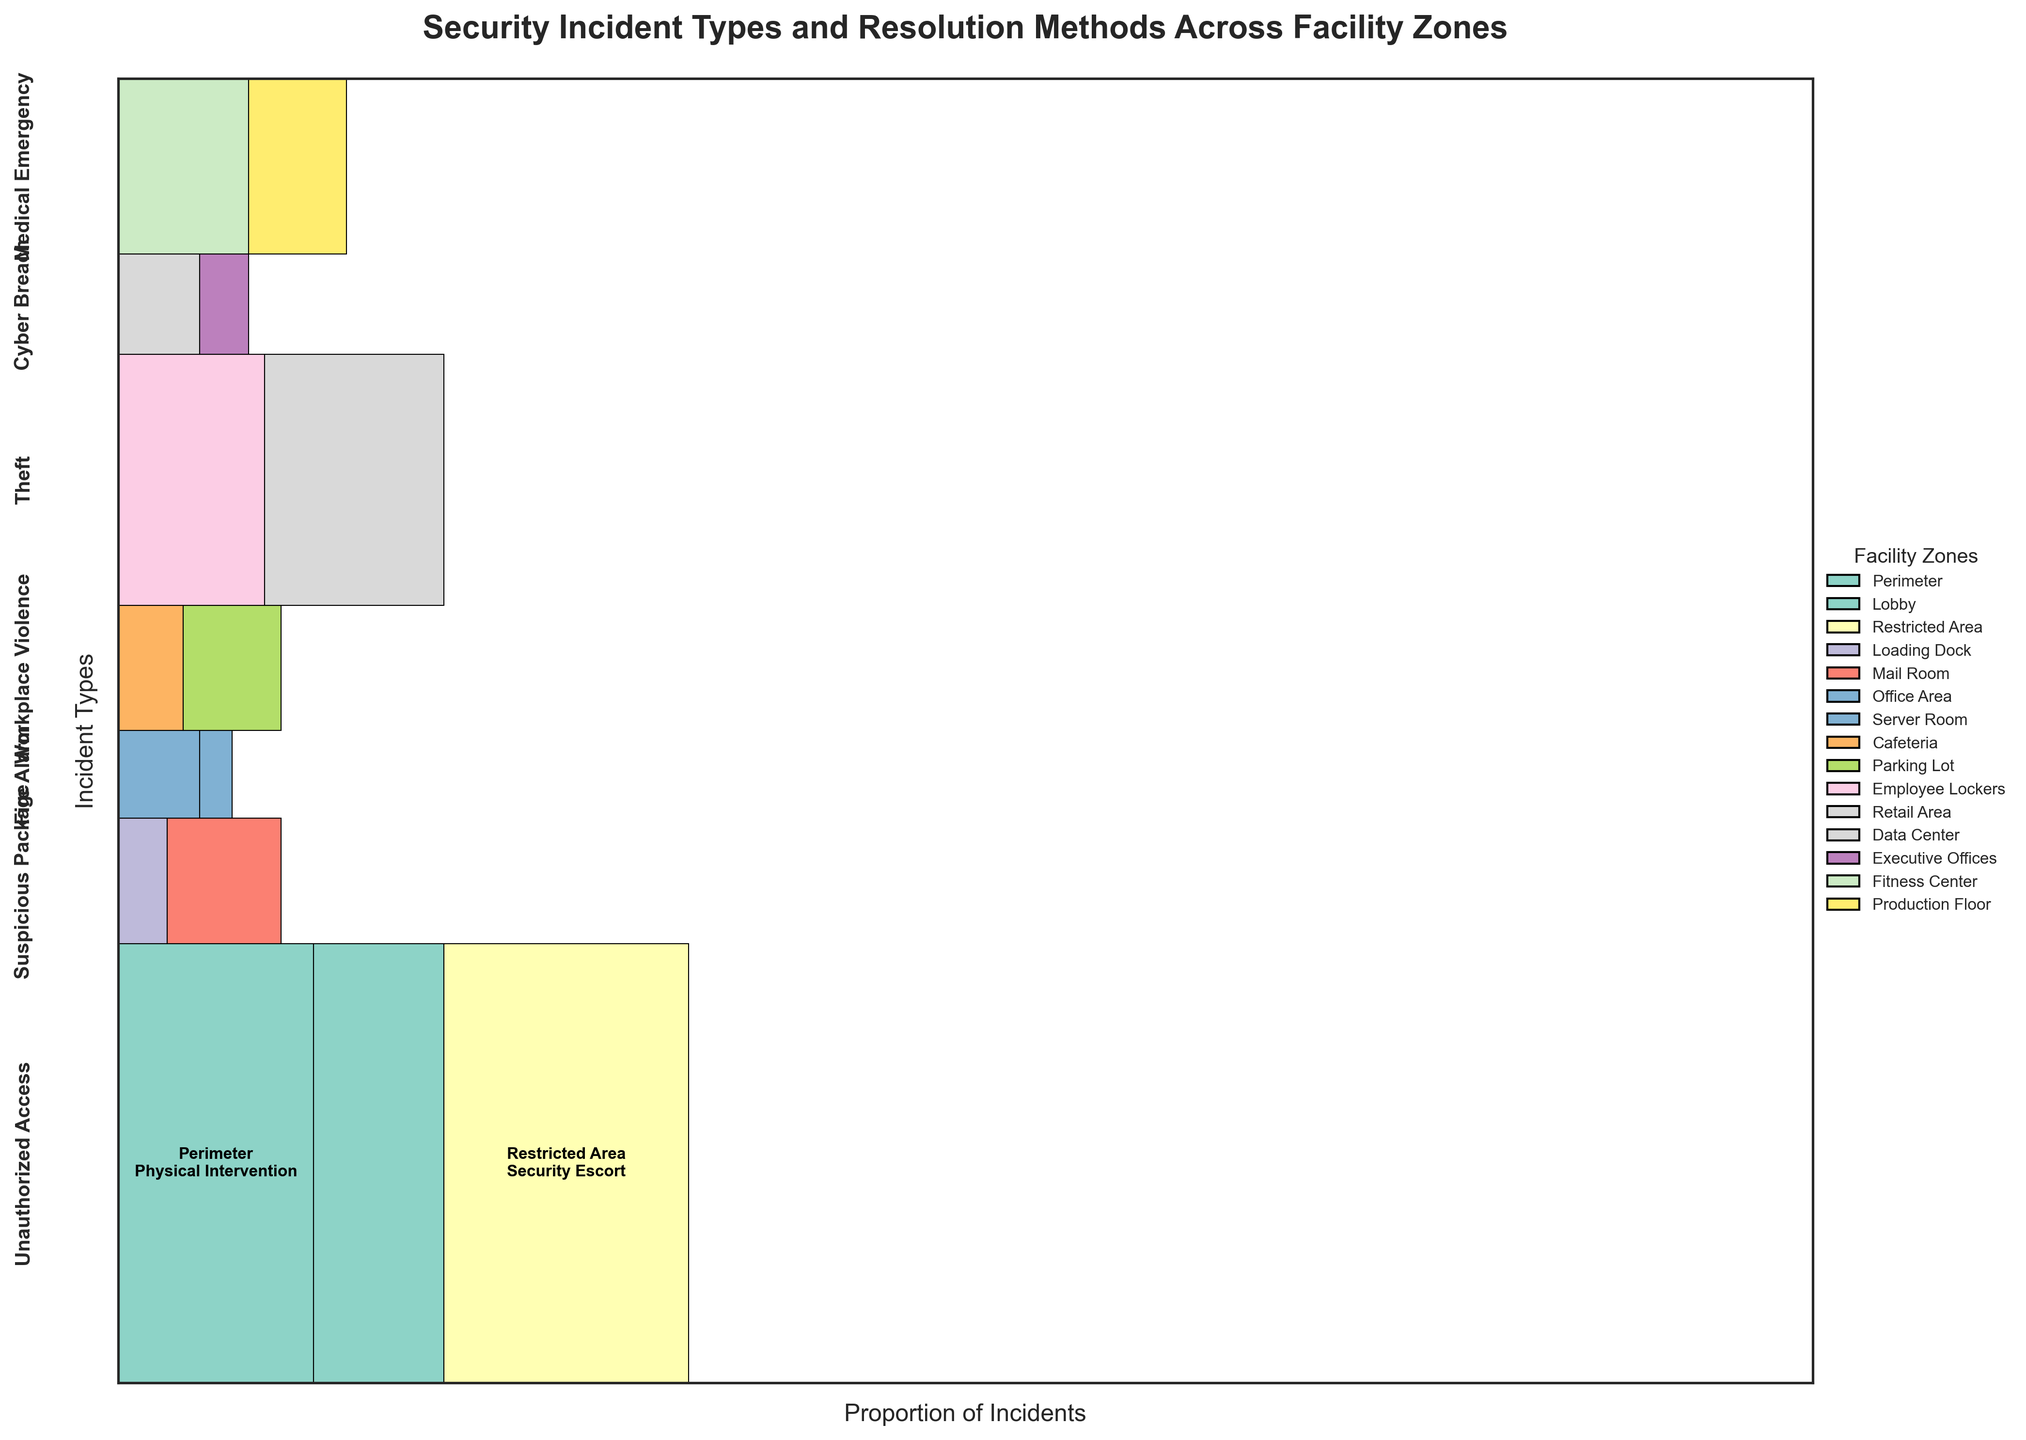what is the title of the plot? The title is usually located at the top of the figure. In this case, the title provides a summary of what the plot represents, which is "Security Incident Types and Resolution Methods Across Facility Zones".
Answer: Security Incident Types and Resolution Methods Across Facility Zones which incident type has the highest total frequency? To determine this, look for the largest section in the plot. The section representing "Unauthorized Access" is the largest, indicating it has the highest total frequency.
Answer: Unauthorized Access how many facility zones are represented in the plot? The legend on the right side of the plot lists all the facility zones. Counting the different colors, there are 13 facility zones shown.
Answer: 13 what is the resolution method for suspicious packages in the mail room? Locate the section for "Suspicious Package" and look for the label corresponding to the "Mail Room" on the mosaic plot. The text within the rectangle shows "X-ray Scanning".
Answer: X-ray Scanning which incident type involves a Bomb Squad intervention and in which facility zone? Locate the section where "Bomb Squad" is mentioned. It is under "Suspicious Package" in the "Loading Dock".
Answer: Suspicious Package, Loading Dock what proportion of medical emergencies occur in the fitness center relative to the production floor? Find the sections for "Medical Emergency" and compare the size of the rectangles for "Fitness Center" and "Production Floor". The "Fitness Center" is larger, indicating more frequent incidents.
Answer: Fitness Center > Production Floor 